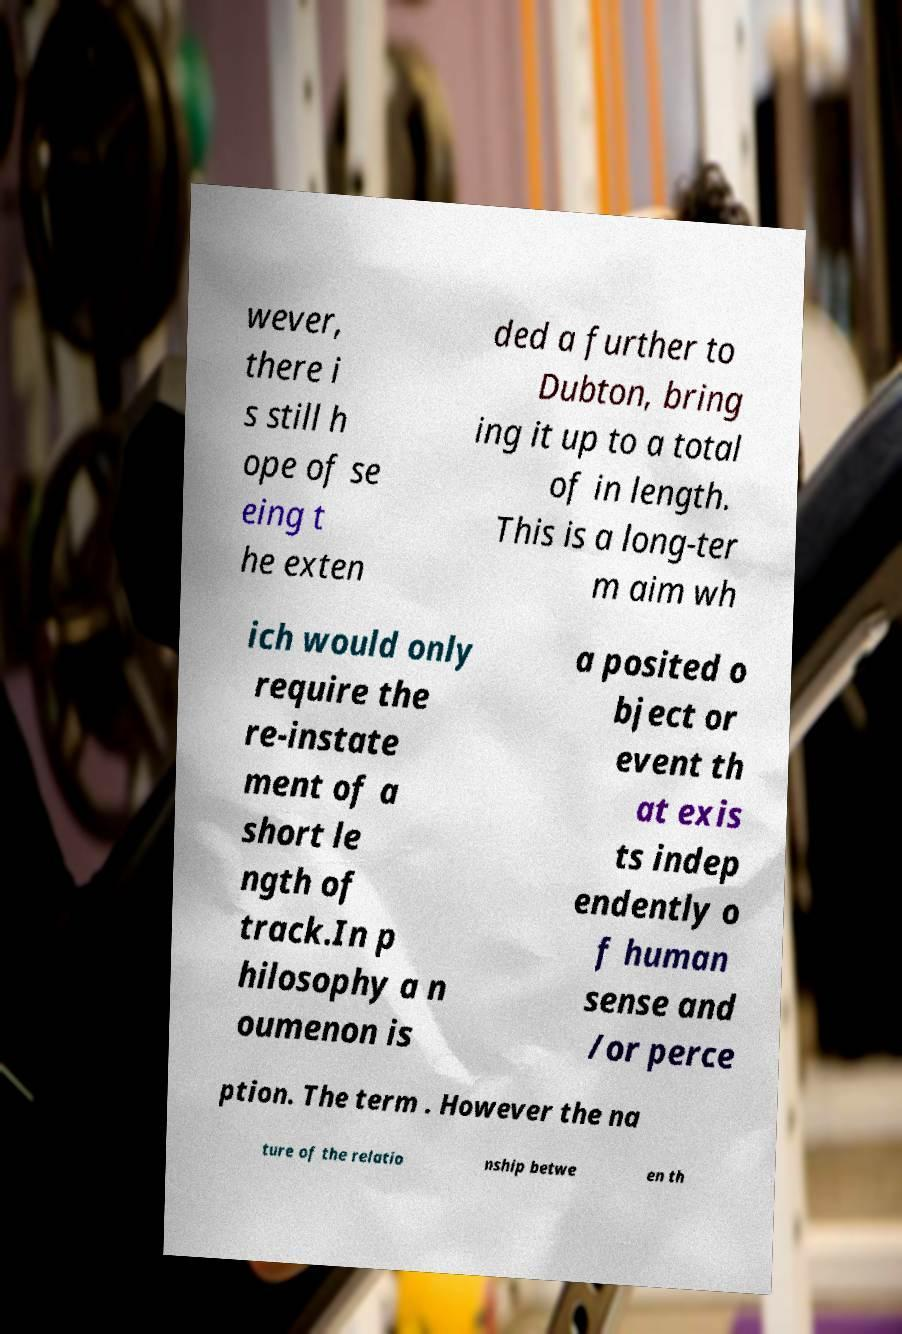Can you read and provide the text displayed in the image?This photo seems to have some interesting text. Can you extract and type it out for me? wever, there i s still h ope of se eing t he exten ded a further to Dubton, bring ing it up to a total of in length. This is a long-ter m aim wh ich would only require the re-instate ment of a short le ngth of track.In p hilosophy a n oumenon is a posited o bject or event th at exis ts indep endently o f human sense and /or perce ption. The term . However the na ture of the relatio nship betwe en th 